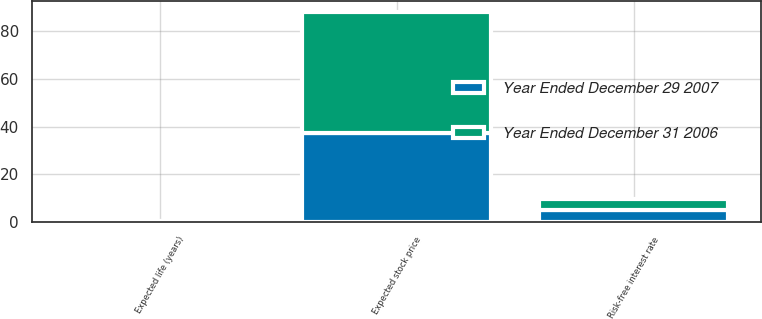<chart> <loc_0><loc_0><loc_500><loc_500><stacked_bar_chart><ecel><fcel>Expected life (years)<fcel>Expected stock price<fcel>Risk-free interest rate<nl><fcel>Year Ended December 29 2007<fcel>0.25<fcel>37.1<fcel>4.92<nl><fcel>Year Ended December 31 2006<fcel>0.25<fcel>51.1<fcel>4.89<nl></chart> 